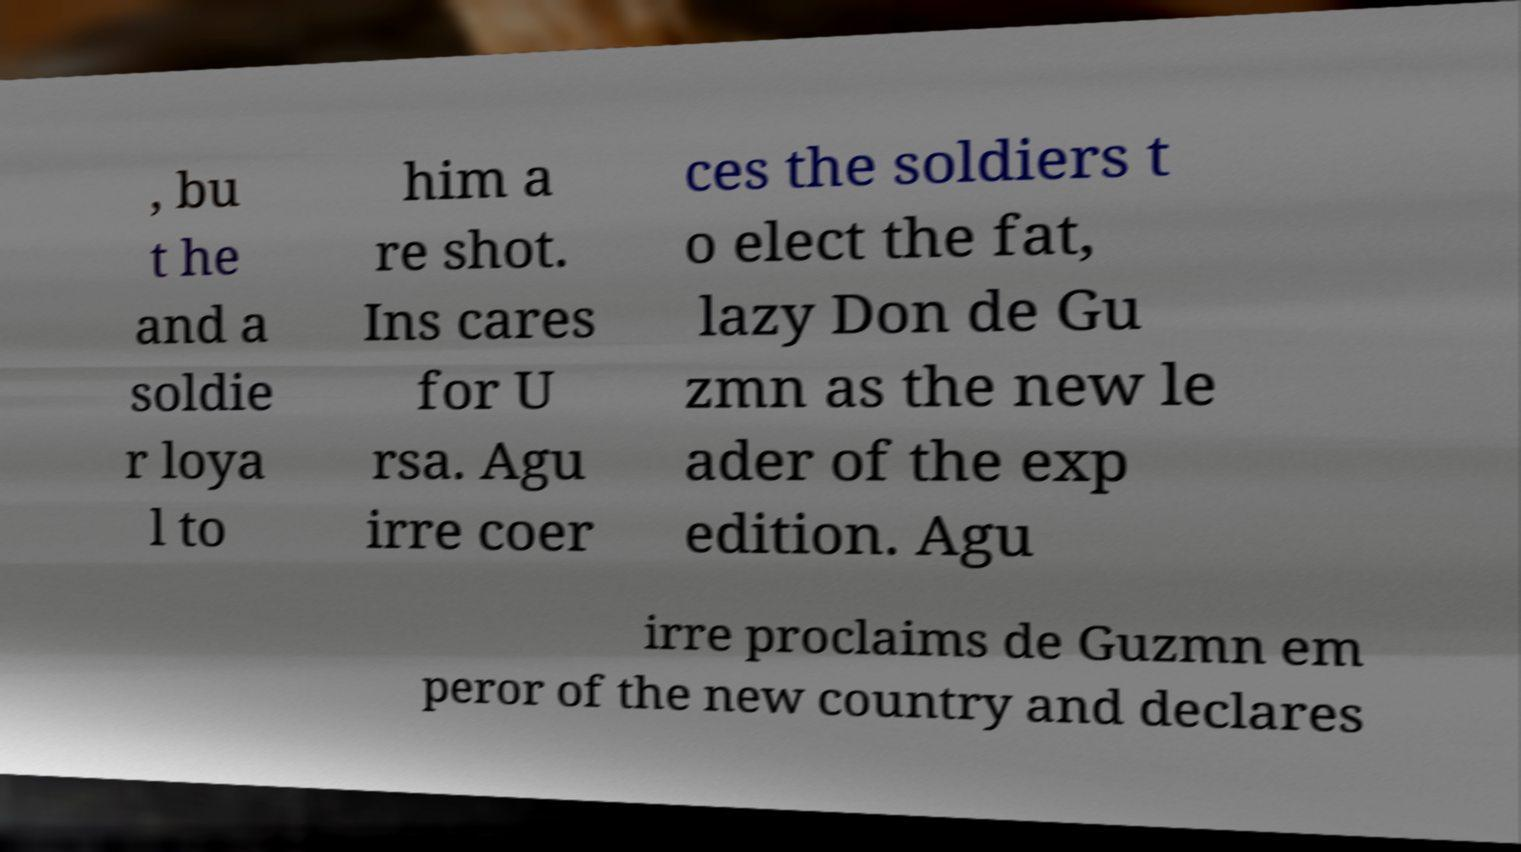Could you extract and type out the text from this image? , bu t he and a soldie r loya l to him a re shot. Ins cares for U rsa. Agu irre coer ces the soldiers t o elect the fat, lazy Don de Gu zmn as the new le ader of the exp edition. Agu irre proclaims de Guzmn em peror of the new country and declares 